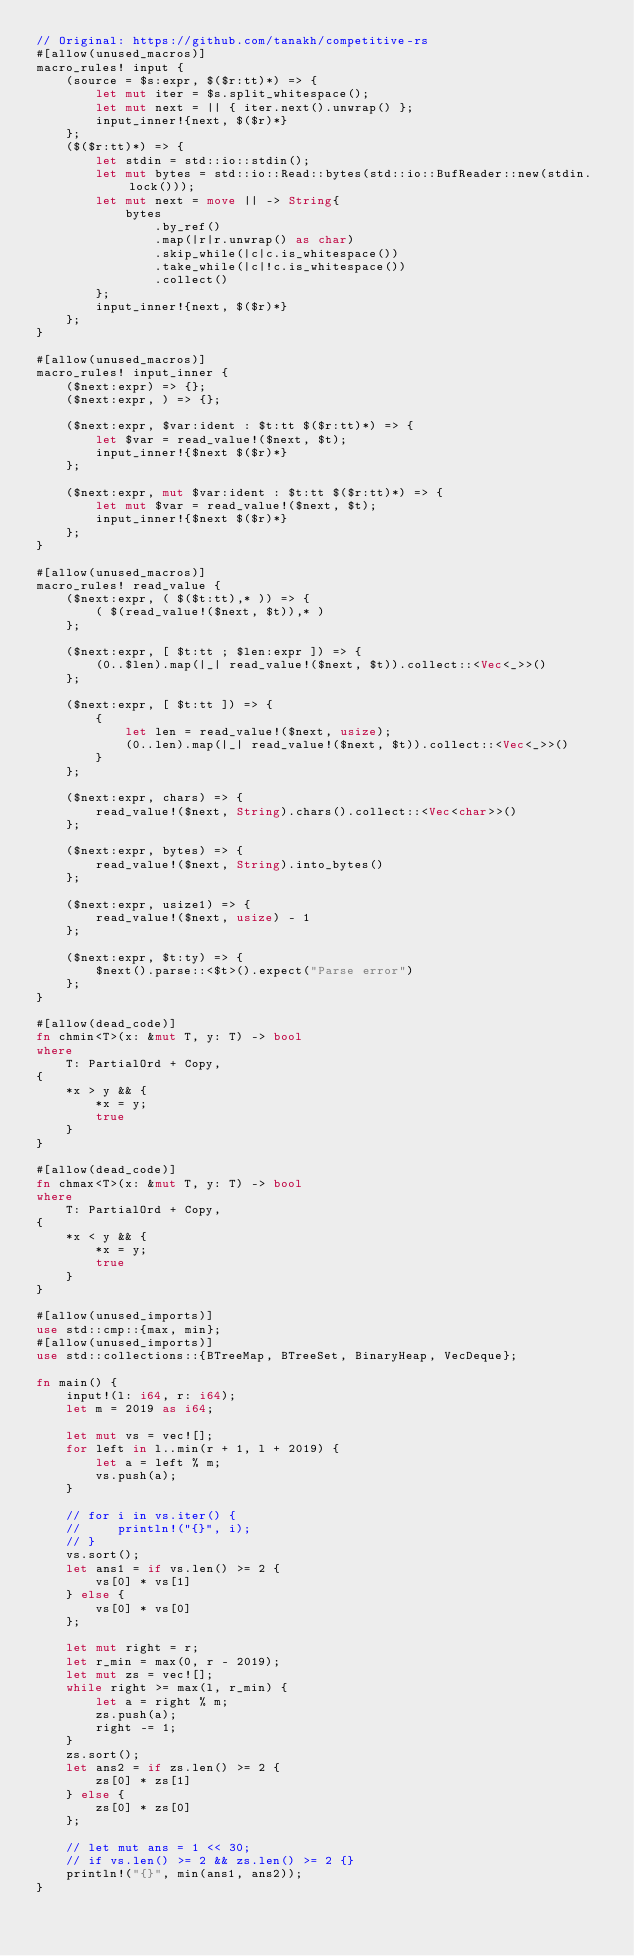Convert code to text. <code><loc_0><loc_0><loc_500><loc_500><_Rust_>// Original: https://github.com/tanakh/competitive-rs
#[allow(unused_macros)]
macro_rules! input {
    (source = $s:expr, $($r:tt)*) => {
        let mut iter = $s.split_whitespace();
        let mut next = || { iter.next().unwrap() };
        input_inner!{next, $($r)*}
    };
    ($($r:tt)*) => {
        let stdin = std::io::stdin();
        let mut bytes = std::io::Read::bytes(std::io::BufReader::new(stdin.lock()));
        let mut next = move || -> String{
            bytes
                .by_ref()
                .map(|r|r.unwrap() as char)
                .skip_while(|c|c.is_whitespace())
                .take_while(|c|!c.is_whitespace())
                .collect()
        };
        input_inner!{next, $($r)*}
    };
}

#[allow(unused_macros)]
macro_rules! input_inner {
    ($next:expr) => {};
    ($next:expr, ) => {};

    ($next:expr, $var:ident : $t:tt $($r:tt)*) => {
        let $var = read_value!($next, $t);
        input_inner!{$next $($r)*}
    };

    ($next:expr, mut $var:ident : $t:tt $($r:tt)*) => {
        let mut $var = read_value!($next, $t);
        input_inner!{$next $($r)*}
    };
}

#[allow(unused_macros)]
macro_rules! read_value {
    ($next:expr, ( $($t:tt),* )) => {
        ( $(read_value!($next, $t)),* )
    };

    ($next:expr, [ $t:tt ; $len:expr ]) => {
        (0..$len).map(|_| read_value!($next, $t)).collect::<Vec<_>>()
    };

    ($next:expr, [ $t:tt ]) => {
        {
            let len = read_value!($next, usize);
            (0..len).map(|_| read_value!($next, $t)).collect::<Vec<_>>()
        }
    };

    ($next:expr, chars) => {
        read_value!($next, String).chars().collect::<Vec<char>>()
    };

    ($next:expr, bytes) => {
        read_value!($next, String).into_bytes()
    };

    ($next:expr, usize1) => {
        read_value!($next, usize) - 1
    };

    ($next:expr, $t:ty) => {
        $next().parse::<$t>().expect("Parse error")
    };
}

#[allow(dead_code)]
fn chmin<T>(x: &mut T, y: T) -> bool
where
    T: PartialOrd + Copy,
{
    *x > y && {
        *x = y;
        true
    }
}

#[allow(dead_code)]
fn chmax<T>(x: &mut T, y: T) -> bool
where
    T: PartialOrd + Copy,
{
    *x < y && {
        *x = y;
        true
    }
}

#[allow(unused_imports)]
use std::cmp::{max, min};
#[allow(unused_imports)]
use std::collections::{BTreeMap, BTreeSet, BinaryHeap, VecDeque};

fn main() {
    input!(l: i64, r: i64);
    let m = 2019 as i64;

    let mut vs = vec![];
    for left in l..min(r + 1, l + 2019) {
        let a = left % m;
        vs.push(a);
    }

    // for i in vs.iter() {
    //     println!("{}", i);
    // }
    vs.sort();
    let ans1 = if vs.len() >= 2 {
        vs[0] * vs[1]
    } else {
        vs[0] * vs[0]
    };

    let mut right = r;
    let r_min = max(0, r - 2019);
    let mut zs = vec![];
    while right >= max(l, r_min) {
        let a = right % m;
        zs.push(a);
        right -= 1;
    }
    zs.sort();
    let ans2 = if zs.len() >= 2 {
        zs[0] * zs[1]
    } else {
        zs[0] * zs[0]
    };

    // let mut ans = 1 << 30;
    // if vs.len() >= 2 && zs.len() >= 2 {}
    println!("{}", min(ans1, ans2));
}
</code> 